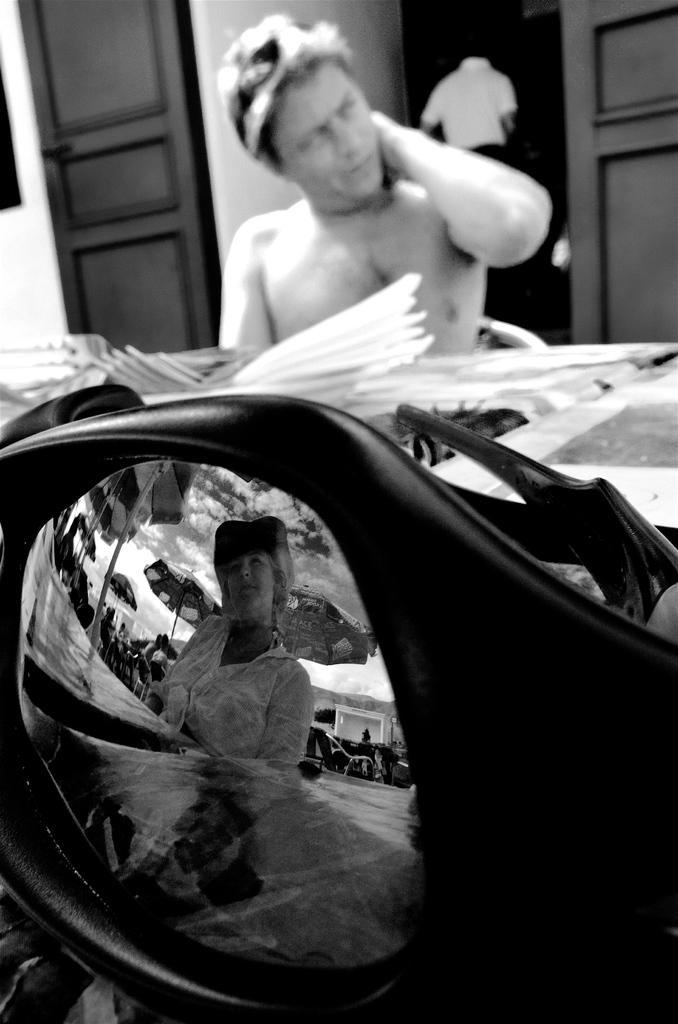Could you give a brief overview of what you see in this image? It is a black and white image. In this image we can see a man sitting in front of the table and on the table we can see the glasses and through the glasses we can see the umbrellas and also the sky with the clouds. In the background of the image we can see a person and also the doors. 